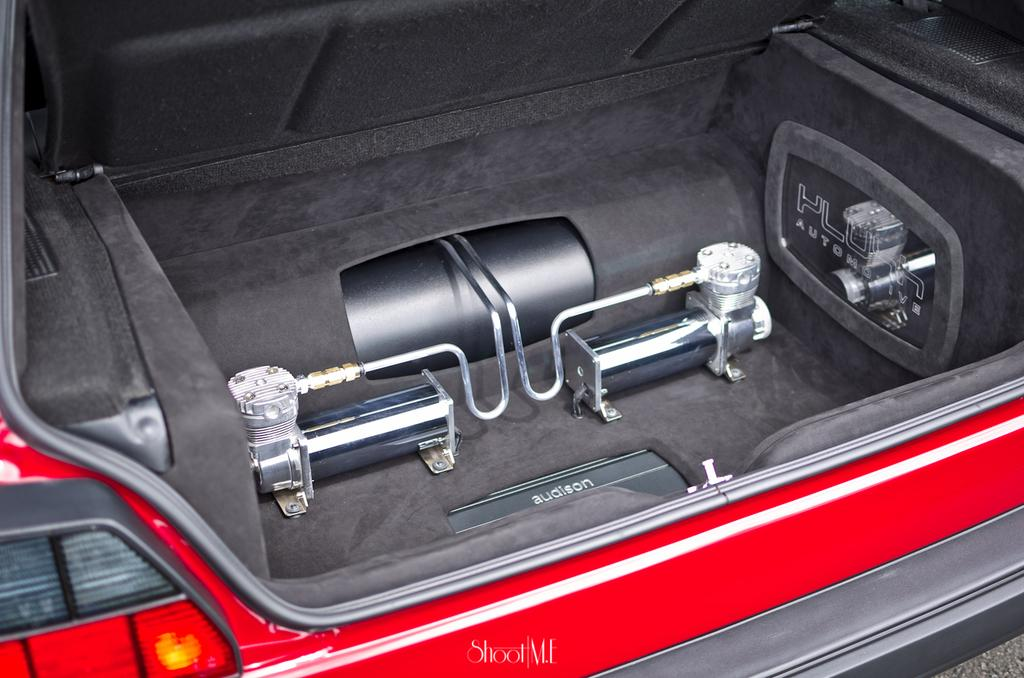What is located in the car trunk in the image? There is an equipment in the car trunk in the image. What color is the car in the image? The car appears to be red in color. What might the equipment in the car trunk be? The equipment might be a tail light. Can you describe any additional features of the image? There is a watermark on the image. Can you see any clover growing near the car in the image? There is no clover visible in the image; it only features a car with a trunk containing equipment and a watermark. 